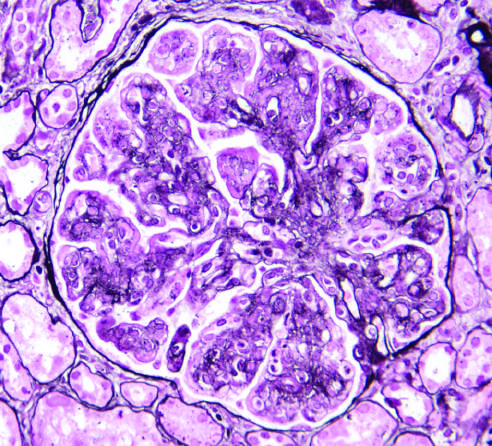did predominance of blastemal morphology and diffuse anaplasia show mesangial cell proliferation, basement membrane duplication, leukocyte infiltration, and accentuation of lobular architecture?
Answer the question using a single word or phrase. No 